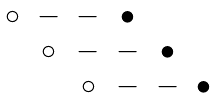Convert formula to latex. <formula><loc_0><loc_0><loc_500><loc_500>\begin{matrix} \circ & - & - & \bullet & & \\ & \circ & - & - & \bullet & \\ & & \circ & - & - & \bullet \\ \end{matrix}</formula> 